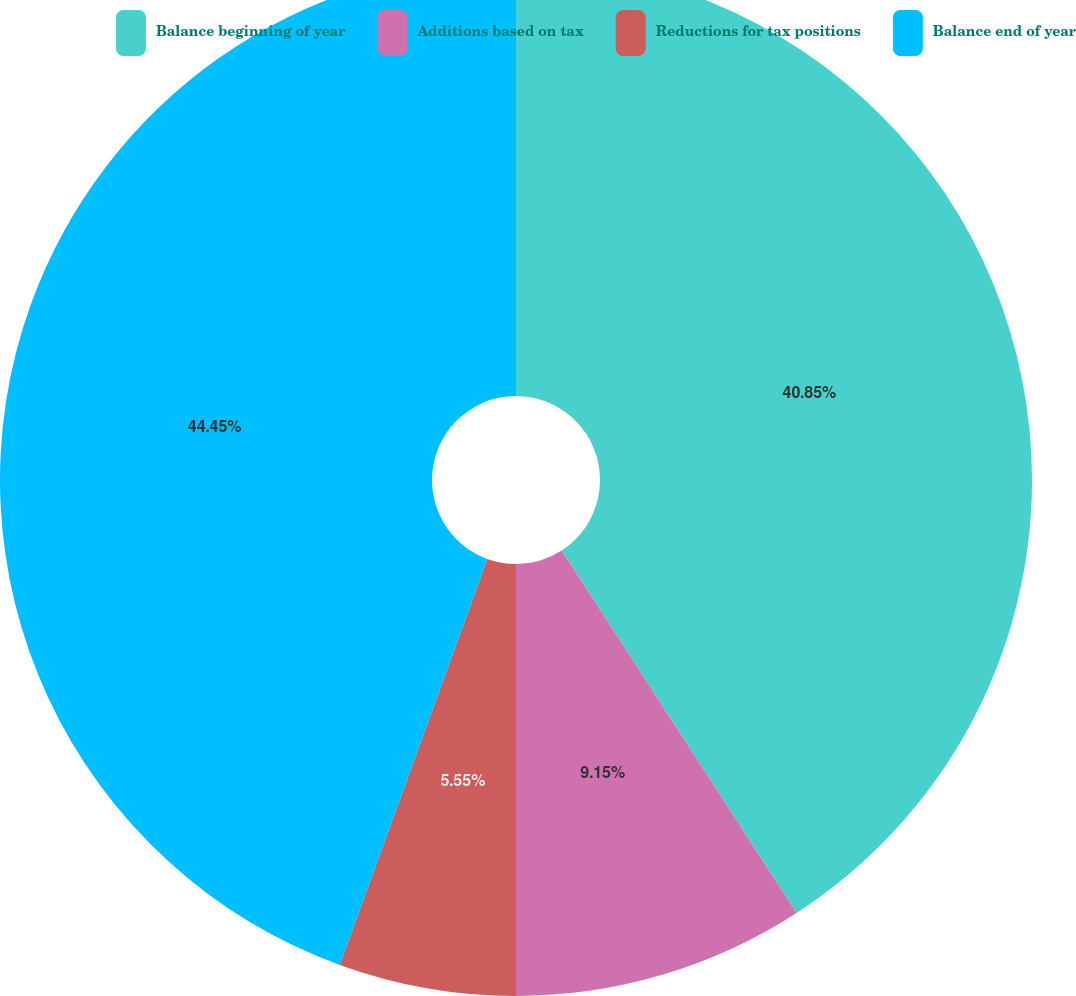Convert chart to OTSL. <chart><loc_0><loc_0><loc_500><loc_500><pie_chart><fcel>Balance beginning of year<fcel>Additions based on tax<fcel>Reductions for tax positions<fcel>Balance end of year<nl><fcel>40.85%<fcel>9.15%<fcel>5.55%<fcel>44.45%<nl></chart> 